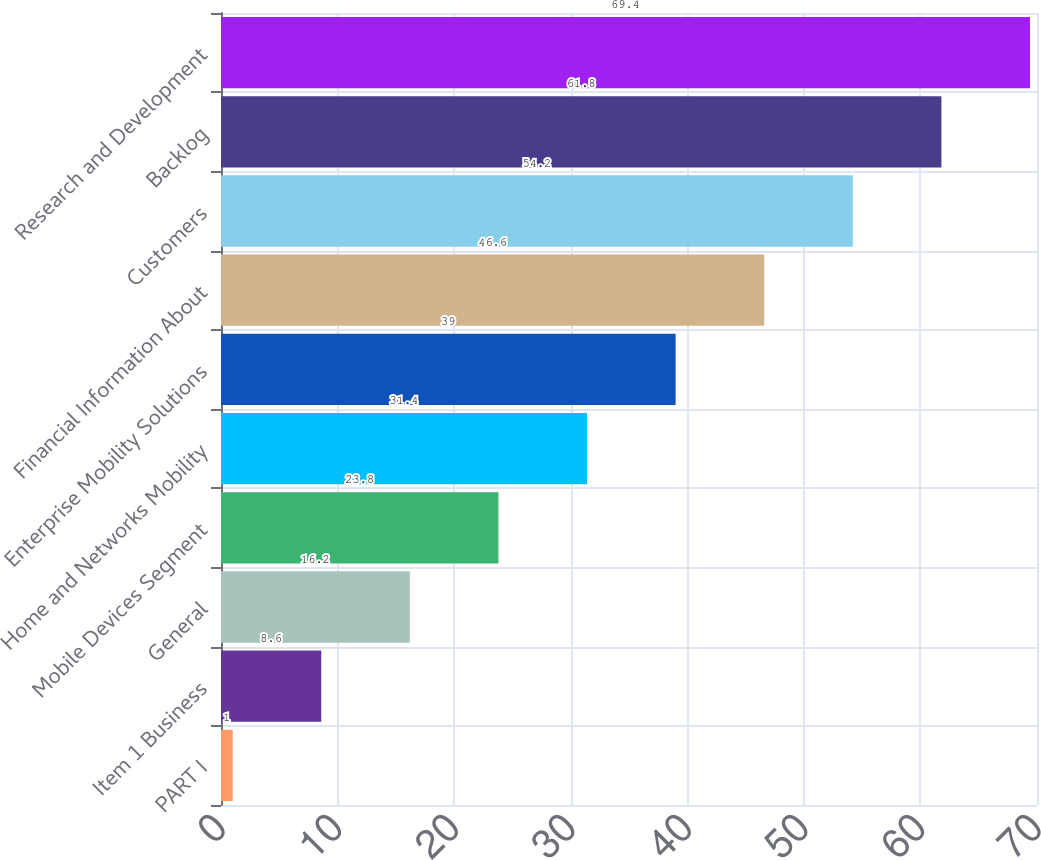Convert chart to OTSL. <chart><loc_0><loc_0><loc_500><loc_500><bar_chart><fcel>PART I<fcel>Item 1 Business<fcel>General<fcel>Mobile Devices Segment<fcel>Home and Networks Mobility<fcel>Enterprise Mobility Solutions<fcel>Financial Information About<fcel>Customers<fcel>Backlog<fcel>Research and Development<nl><fcel>1<fcel>8.6<fcel>16.2<fcel>23.8<fcel>31.4<fcel>39<fcel>46.6<fcel>54.2<fcel>61.8<fcel>69.4<nl></chart> 